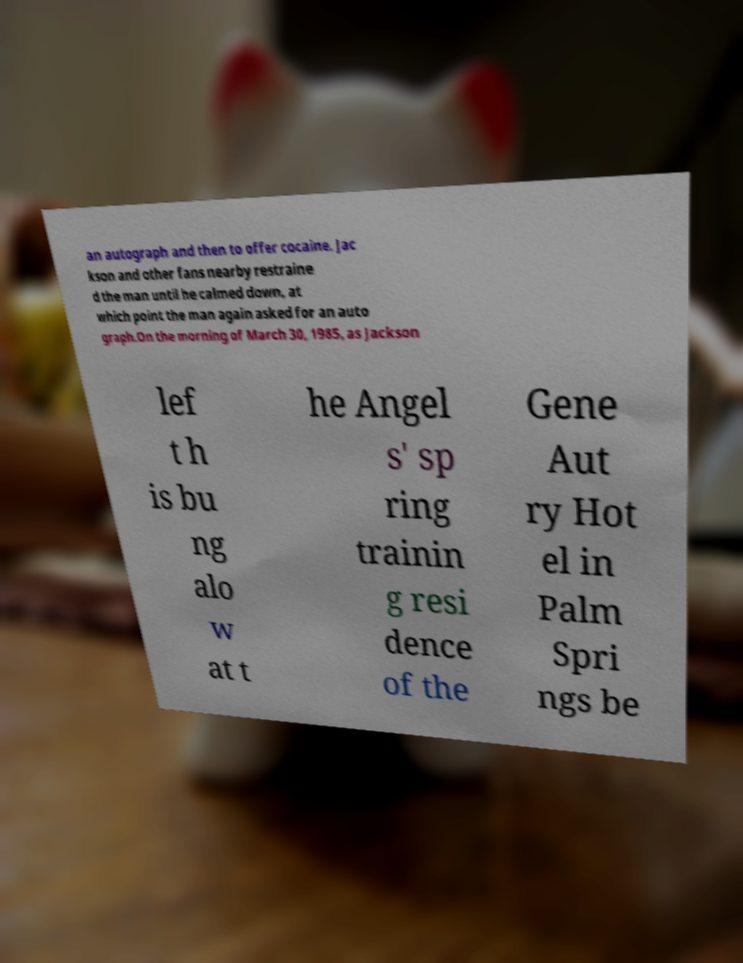For documentation purposes, I need the text within this image transcribed. Could you provide that? an autograph and then to offer cocaine. Jac kson and other fans nearby restraine d the man until he calmed down, at which point the man again asked for an auto graph.On the morning of March 30, 1985, as Jackson lef t h is bu ng alo w at t he Angel s' sp ring trainin g resi dence of the Gene Aut ry Hot el in Palm Spri ngs be 